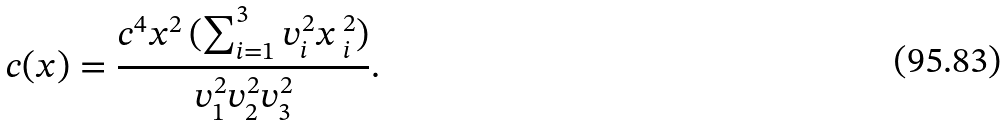<formula> <loc_0><loc_0><loc_500><loc_500>c ( x ) = \frac { c ^ { 4 } x ^ { 2 } \, ( \sum ^ { 3 } _ { i = 1 } v ^ { 2 } _ { i } x \, ^ { 2 } _ { i } ) } { v ^ { 2 } _ { 1 } v ^ { 2 } _ { 2 } v ^ { 2 } _ { 3 } } .</formula> 